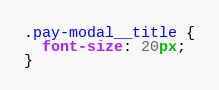Convert code to text. <code><loc_0><loc_0><loc_500><loc_500><_CSS_>.pay-modal__title {
  font-size: 20px;
}</code> 